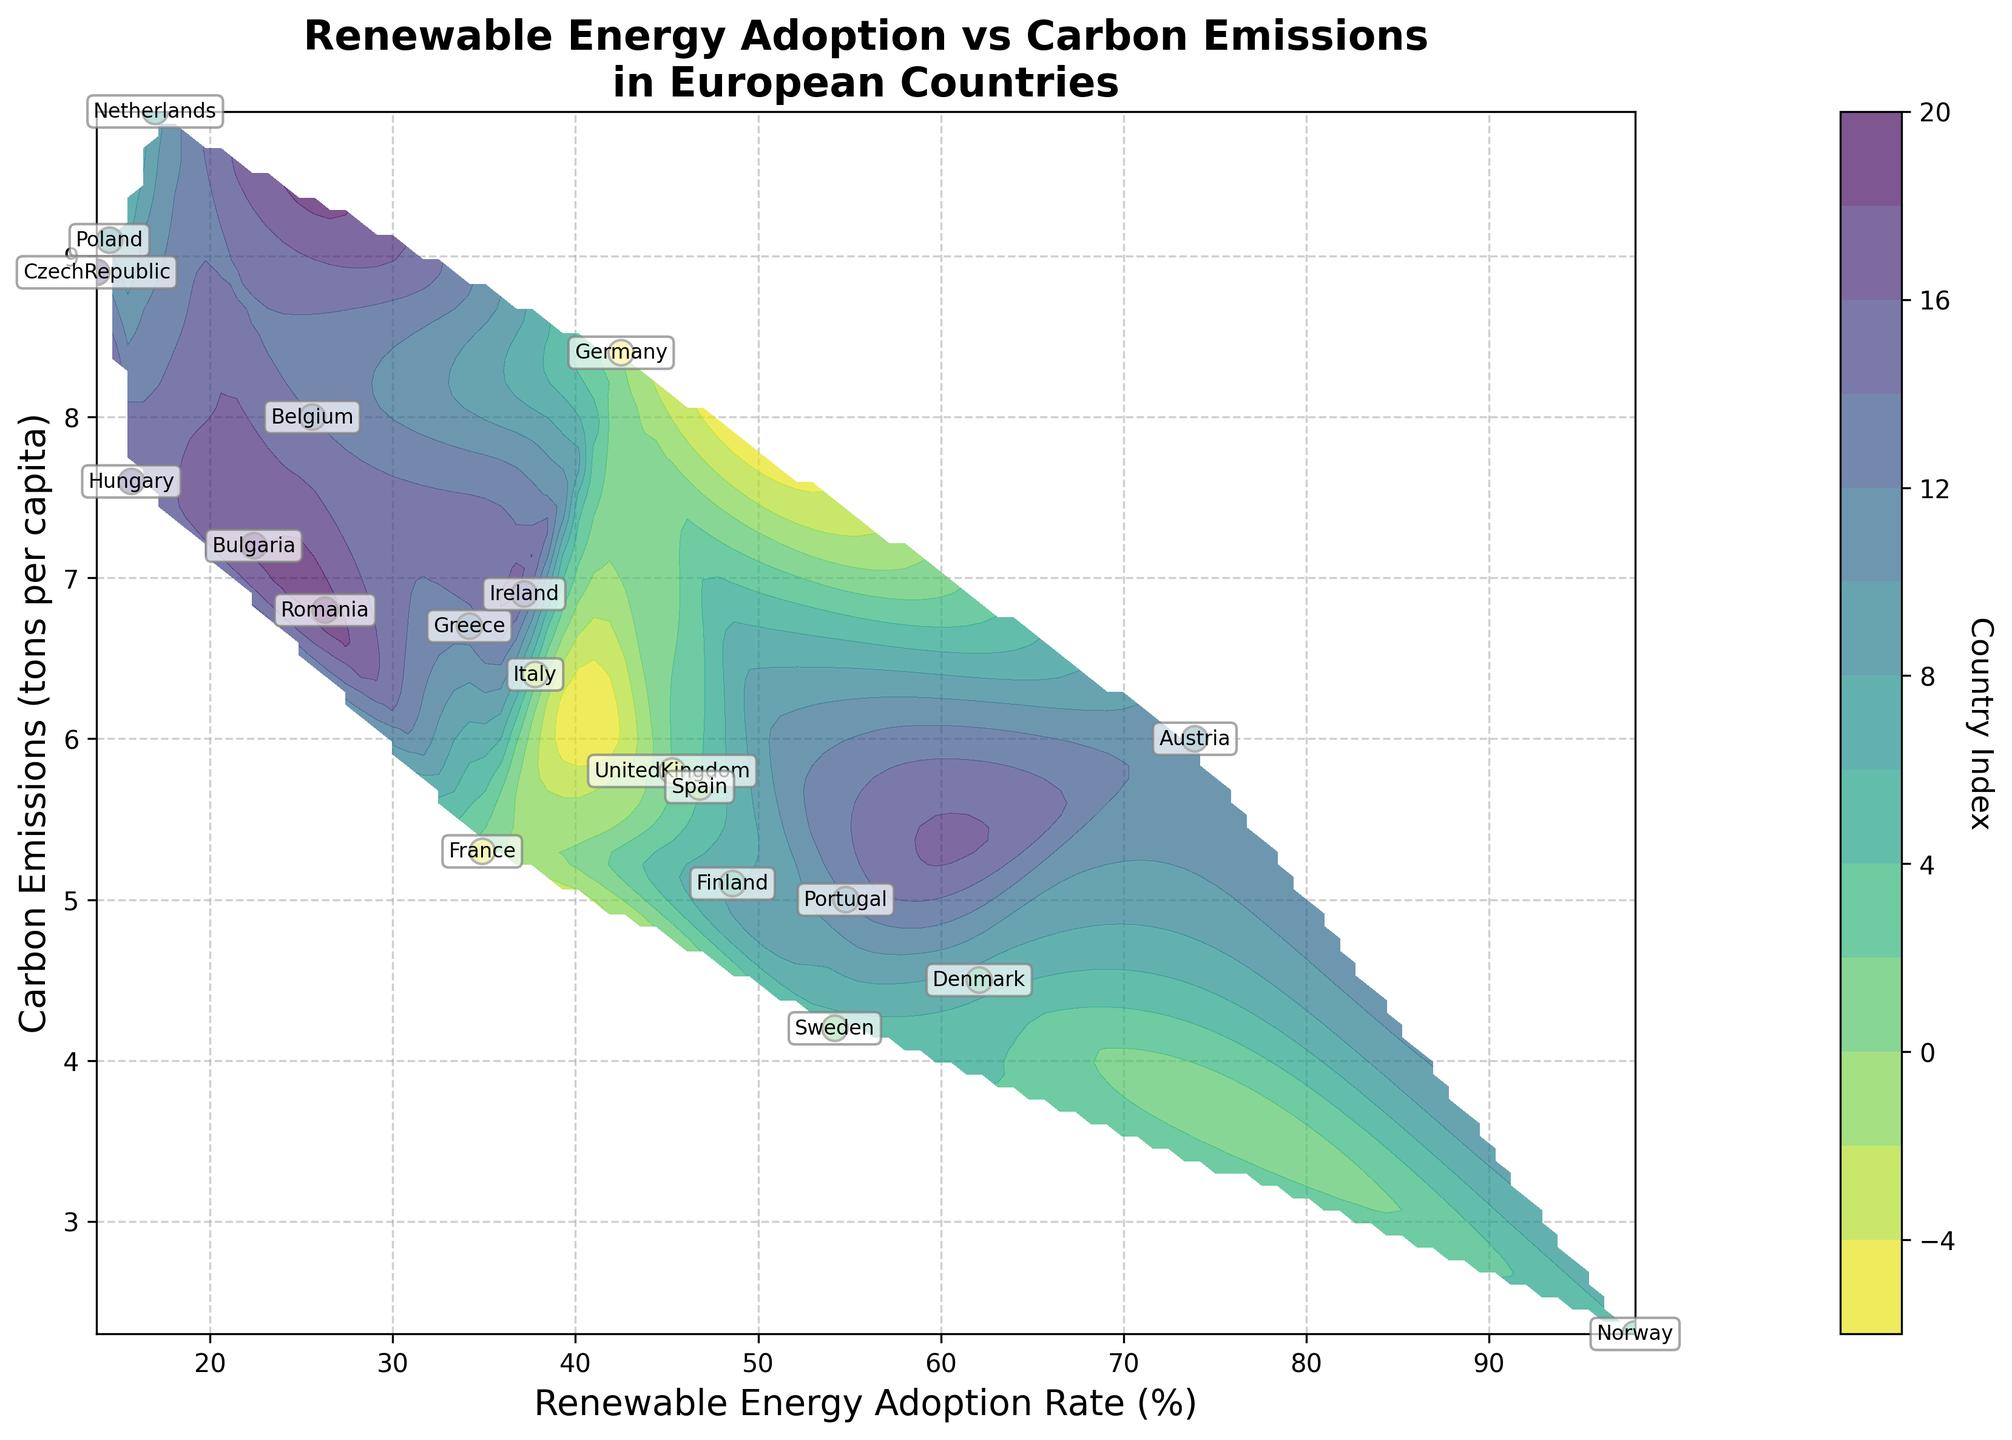What is the title of the figure? The title of the figure is displayed prominently at the top. The text reads 'Renewable Energy Adoption vs Carbon Emissions in European Countries'.
Answer: Renewable Energy Adoption vs Carbon Emissions in European Countries How many countries are represented in the plot? Each data point represents a country. By counting the data points or annotations, we find 19 countries.
Answer: 19 Which country has the highest renewable energy adoption rate? The country with the highest renewable energy adoption rate will be positioned farthest to the right on the x-axis. From the plot, Norway is at nearly 100% adoption.
Answer: Norway What is the range of carbon emissions shown in the plot? The range can be determined by looking at the y-axis values from the lowest to the highest point on the plot. Carbon emissions range from approximately 2.3 to 9.9 tons per capita.
Answer: 2.3 to 9.9 tons per capita Which country has the lowest carbon emissions, and what is its renewable energy adoption rate? The country with the lowest carbon emissions will be positioned lowest on the y-axis. Norway has the lowest carbon emissions (2.3 tons per capita), and it has nearly 100% renewable energy adoption rate.
Answer: Norway, ~100% Compare the carbon emissions between the country with the highest renewable adoption rate and the country with the lowest adoption rate. Norway has the highest renewable energy adoption rate (~100%) and the lowest carbon emissions (2.3 tons per capita). The Netherlands has the lowest renewable adoption rate (17.0%) and carbon emissions of 9.9 tons per capita. Norway has significantly lower emissions compared to the Netherlands.
Answer: Norway has lower emissions than the Netherlands Which countries have both high renewable energy adoption rates (above 50%) and low carbon emissions (below 5 tons per capita)? By observing the plots within the specified ranges, we identify Sweden, Denmark, and Portugal as countries with renewable energy adoption rates above 50% and carbon emissions below 5 tons per capita.
Answer: Sweden, Denmark, Portugal How do the renewable energy adoption rates generally relate to carbon emissions? There is a trend visible in the plot showing that, in general, higher renewable energy adoption rates are associated with lower carbon emissions. This can be inferred by observing the relative positions of data points on the plot.
Answer: Generally, higher adoption rates relate to lower emissions Which country has a renewable energy adoption rate closest to 40% and what are its carbon emissions? By locating the data point closest to 40% on the x-axis, we find Ireland with a renewable energy adoption rate of 37.2% and carbon emissions of 6.9 tons per capita.
Answer: Ireland, 6.9 tons per capita What is the approximate median renewable energy adoption rate for the countries in the plot? To determine the median, we sort the adoption rates and find the middle value. The sorted rates are: 13.8, 14.5, 15.7, 17.0, 22.4, 25.6, 26.3, 34.2, 34.9, 37.2, 37.8, 42.5, 45.3, 46.8, 48.6, 54.2, 54.8, 62.1, 73.9, 98.0. The middle value is 37.8%.
Answer: 37.8% 